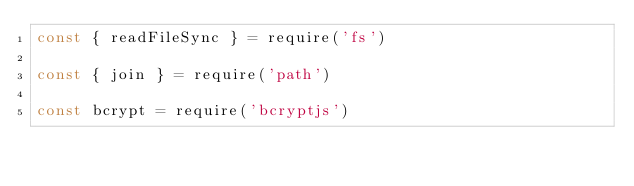<code> <loc_0><loc_0><loc_500><loc_500><_JavaScript_>const { readFileSync } = require('fs')

const { join } = require('path')

const bcrypt = require('bcryptjs')
</code> 